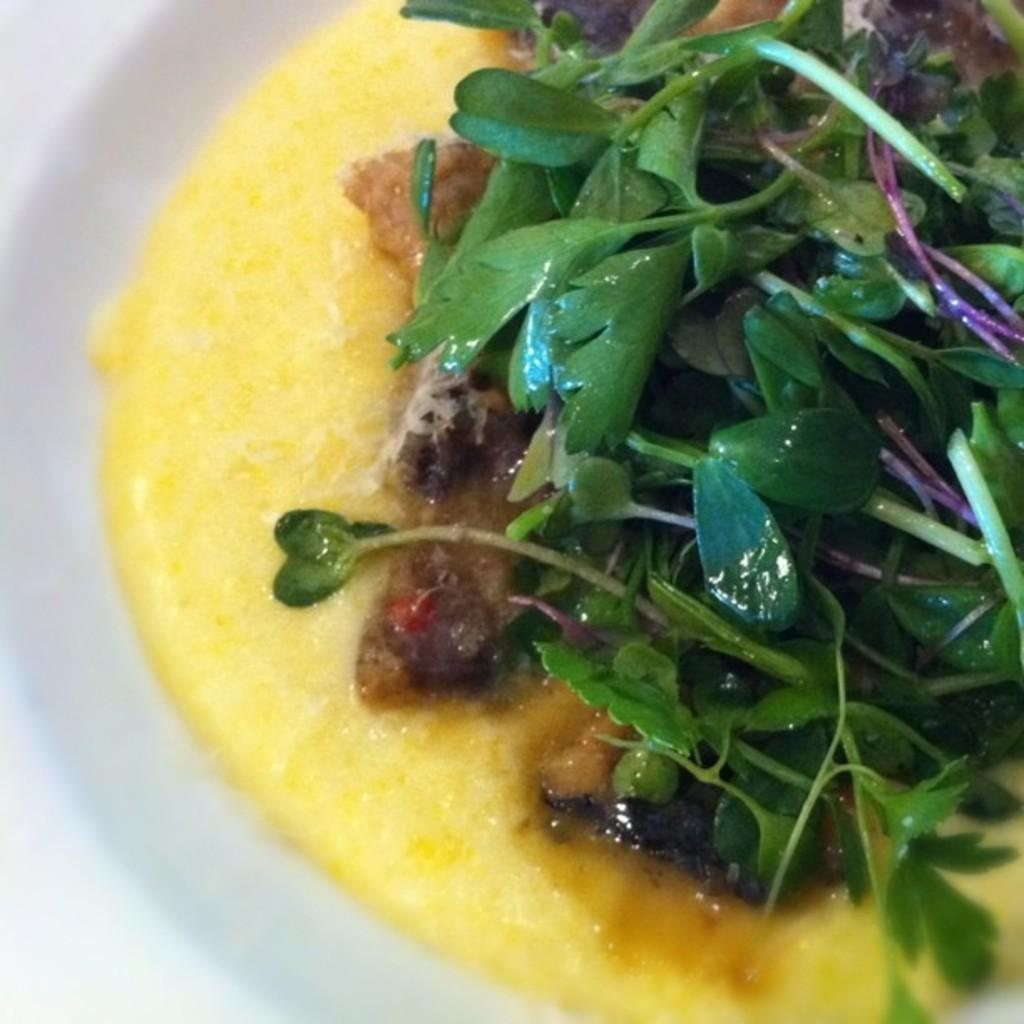What is present on the plate in the image? There are food items on the plate in the image. Can you describe the plate in more detail? Unfortunately, the facts provided do not give any additional details about the plate. What type of slip is the uncle wearing in the image? There is no uncle or slip present in the image. How many zippers can be seen on the food items in the image? There are no zippers on the food items in the image, as food items do not have zippers. 